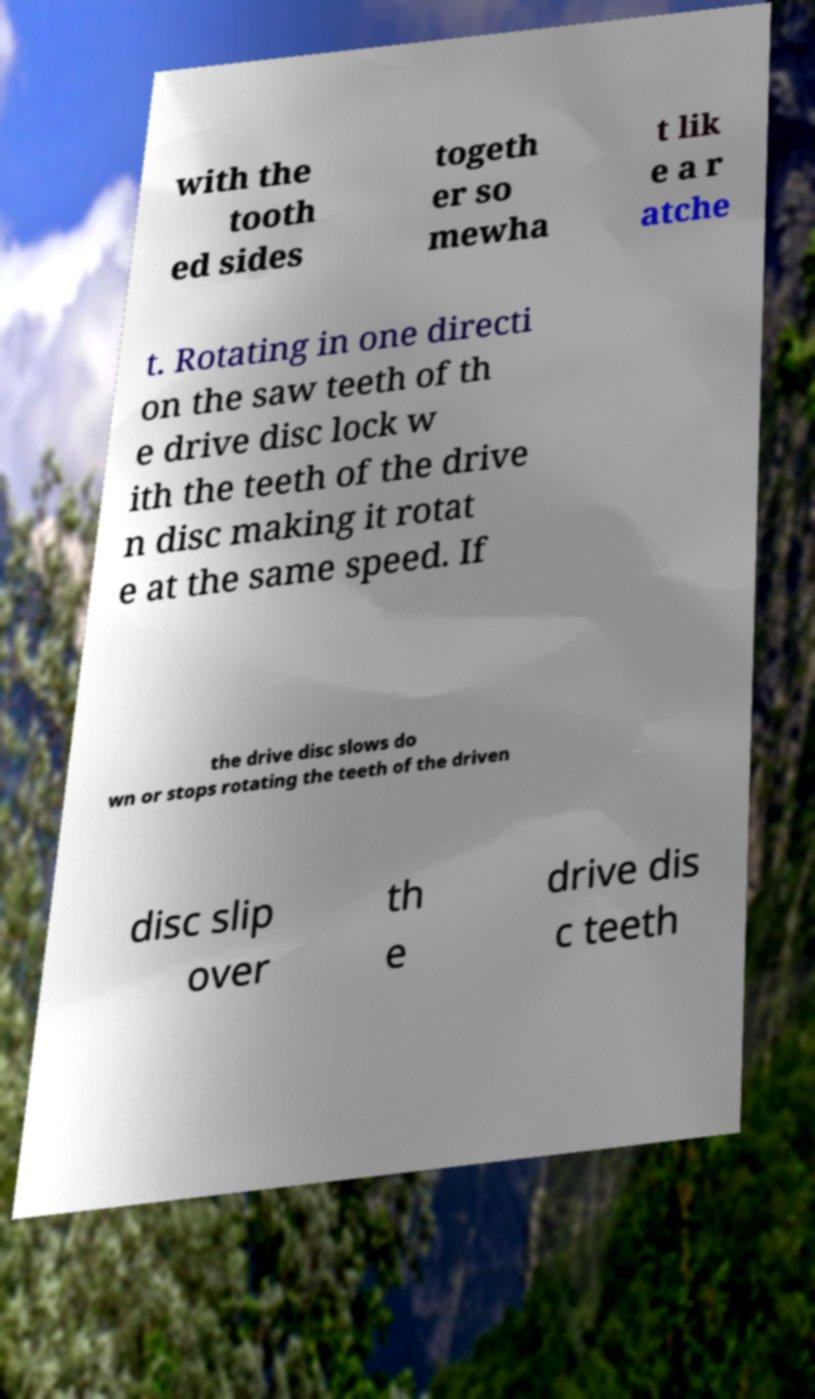Please identify and transcribe the text found in this image. with the tooth ed sides togeth er so mewha t lik e a r atche t. Rotating in one directi on the saw teeth of th e drive disc lock w ith the teeth of the drive n disc making it rotat e at the same speed. If the drive disc slows do wn or stops rotating the teeth of the driven disc slip over th e drive dis c teeth 